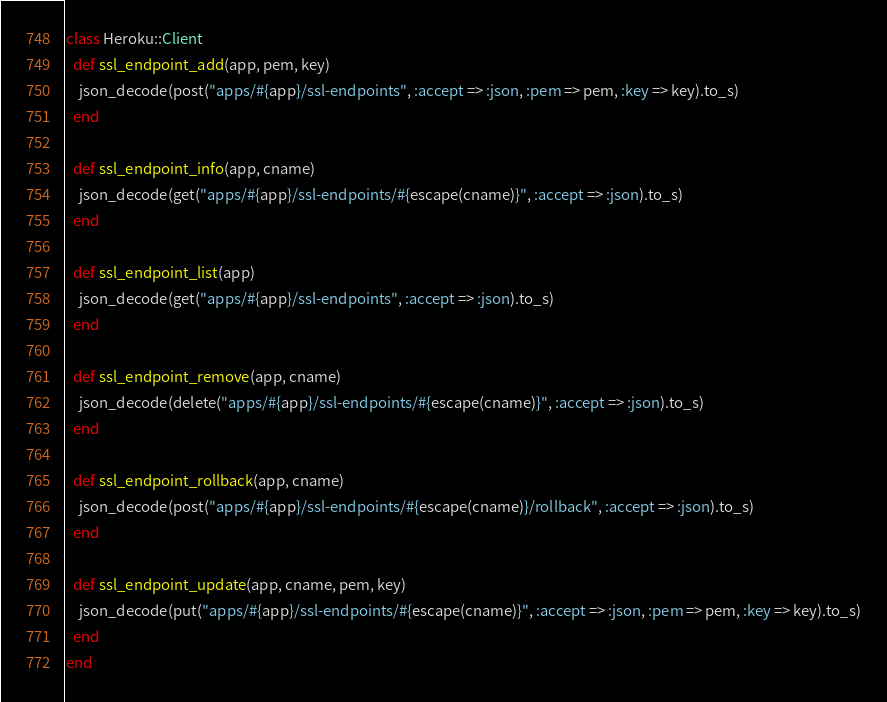<code> <loc_0><loc_0><loc_500><loc_500><_Ruby_>class Heroku::Client
  def ssl_endpoint_add(app, pem, key)
    json_decode(post("apps/#{app}/ssl-endpoints", :accept => :json, :pem => pem, :key => key).to_s)
  end

  def ssl_endpoint_info(app, cname)
    json_decode(get("apps/#{app}/ssl-endpoints/#{escape(cname)}", :accept => :json).to_s)
  end

  def ssl_endpoint_list(app)
    json_decode(get("apps/#{app}/ssl-endpoints", :accept => :json).to_s)
  end

  def ssl_endpoint_remove(app, cname)
    json_decode(delete("apps/#{app}/ssl-endpoints/#{escape(cname)}", :accept => :json).to_s)
  end

  def ssl_endpoint_rollback(app, cname)
    json_decode(post("apps/#{app}/ssl-endpoints/#{escape(cname)}/rollback", :accept => :json).to_s)
  end

  def ssl_endpoint_update(app, cname, pem, key)
    json_decode(put("apps/#{app}/ssl-endpoints/#{escape(cname)}", :accept => :json, :pem => pem, :key => key).to_s)
  end
end
</code> 